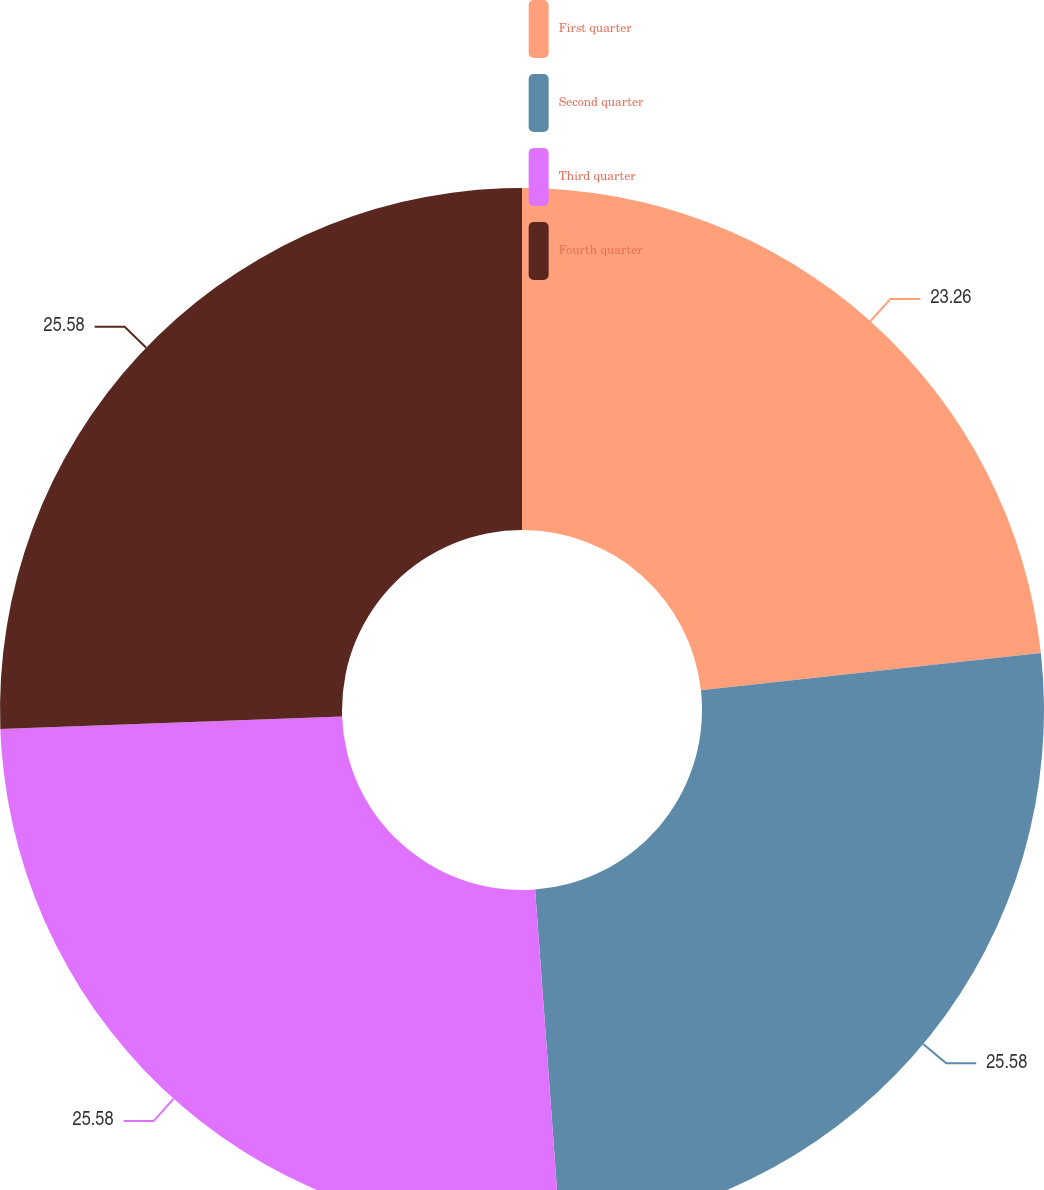Convert chart. <chart><loc_0><loc_0><loc_500><loc_500><pie_chart><fcel>First quarter<fcel>Second quarter<fcel>Third quarter<fcel>Fourth quarter<nl><fcel>23.26%<fcel>25.58%<fcel>25.58%<fcel>25.58%<nl></chart> 